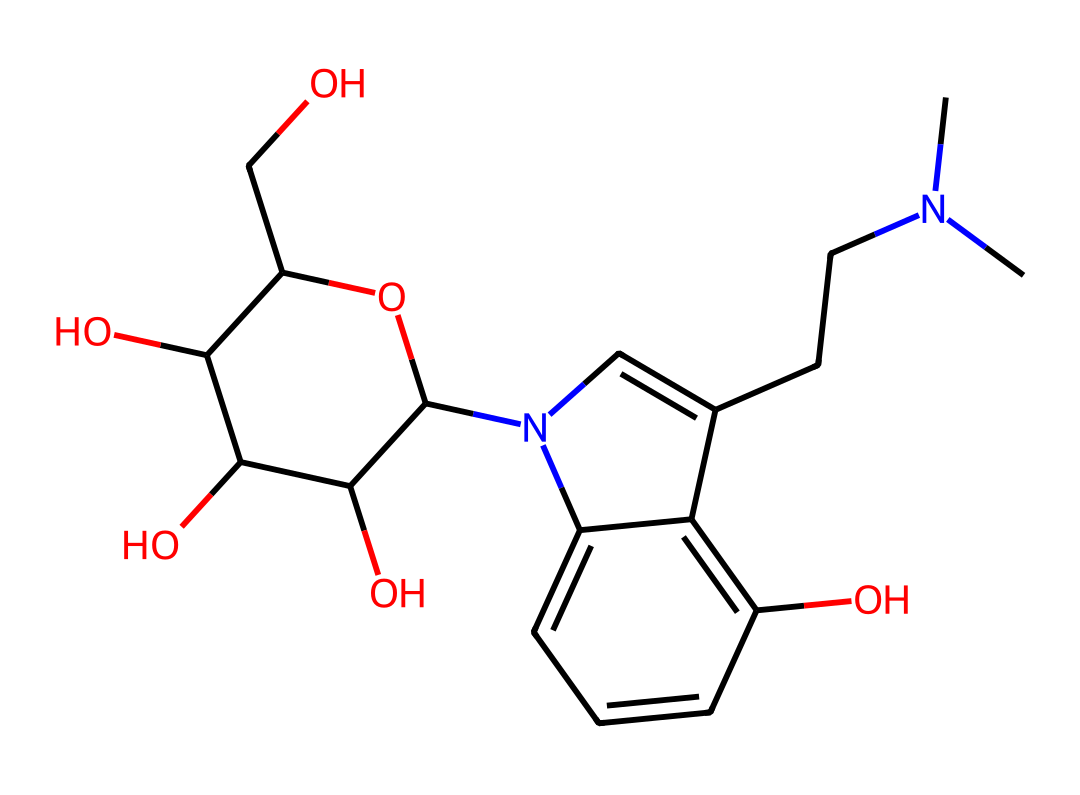what is the molecular formula of psilocybin? To determine the molecular formula, count the number of each type of atom in the SMILES representation. The atoms present are Carbon (C), Hydrogen (H), Nitrogen (N), and Oxygen (O). By analyzing the structure, we find there are 12 carbons, 17 hydrogens, 2 nitrogens, and 4 oxygens, leading to the formula C12H17N2O4P.
Answer: C12H17N2O4P how many rings are present in the psilocybin structure? By examining the SMILES notation and the appearances of 'c' and 'n' indicating aromatic carbon and nitrogen in the cyclic part of the structure, we can identify two distinct rings in the structure of psilocybin.
Answer: 2 does psilocybin contain nitrogen atoms? The presence of carbon bonds to 'N' in the SMILES indicates that nitrogen is part of the molecular structure. We can directly observe two nitrogen atoms in the structure as indicated by the 'N' in the SMILES.
Answer: yes which part of the molecule contributes to its potential psychedelic effects? The portion of the molecule that influences its psychedelic effects is primarily the indole ring which includes the nitrogen atoms and aromatic structure. This structure is characteristic of many psychedelics like psilocybin and contributes to binding at serotonin receptors in the brain.
Answer: indole ring is psilocybin considered an antioxidant compound? The structure is analyzed for functional groups that are commonly associated with antioxidant properties. The hydroxyl groups (-OH) present in the molecule are typically responsible for antioxidant activity by scavenging free radicals, which makes it reasonable to categorize psilocybin as an antioxidant.
Answer: yes 